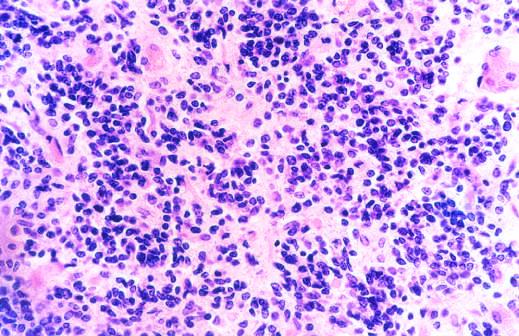what did the microscopic appearance of medulloblastoma show?
Answer the question using a single word or phrase. Small 